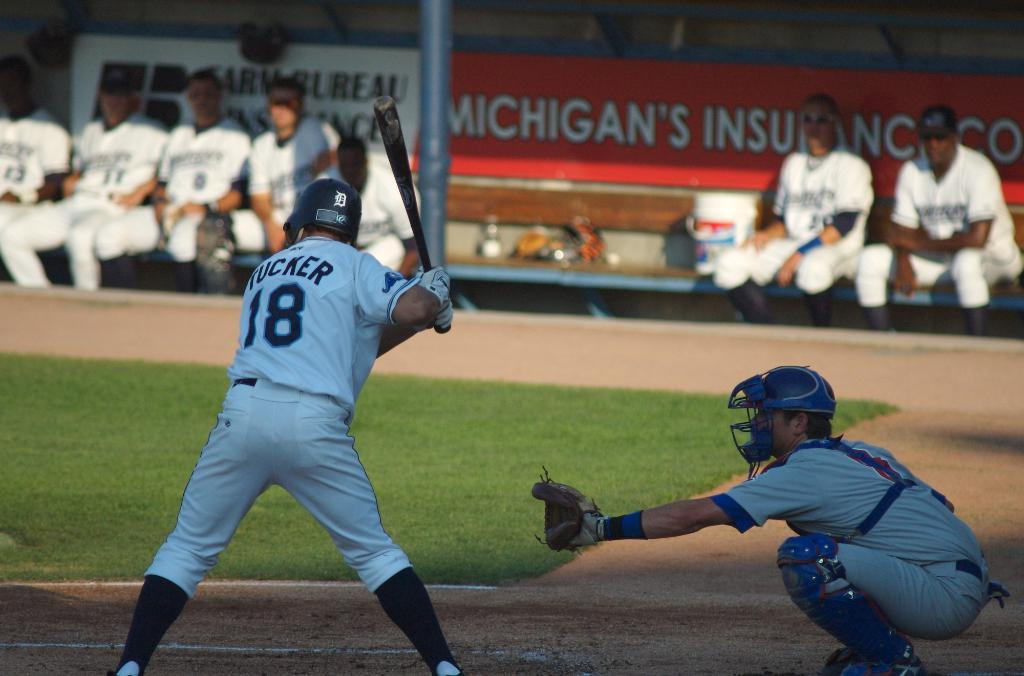<image>
Provide a brief description of the given image. A player named Tucker wears jersey number 18 and is at-bat. 